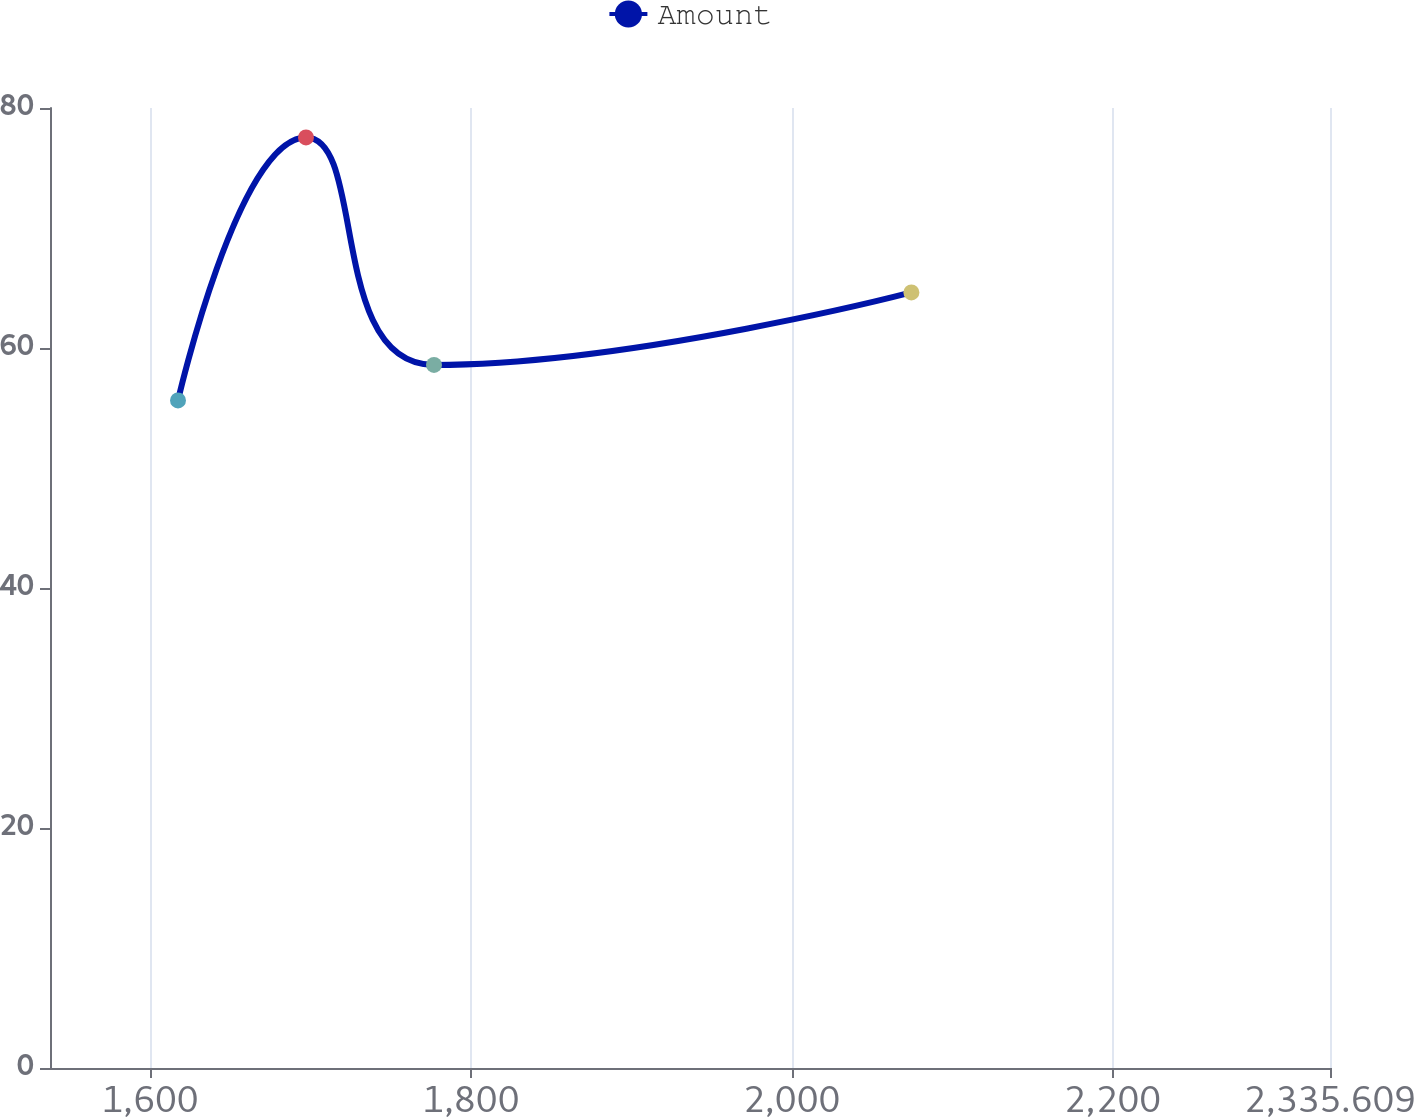<chart> <loc_0><loc_0><loc_500><loc_500><line_chart><ecel><fcel>Amount<nl><fcel>1617.49<fcel>55.63<nl><fcel>1697.28<fcel>77.55<nl><fcel>1777.07<fcel>58.59<nl><fcel>2074.66<fcel>64.63<nl><fcel>2415.4<fcel>66.82<nl></chart> 